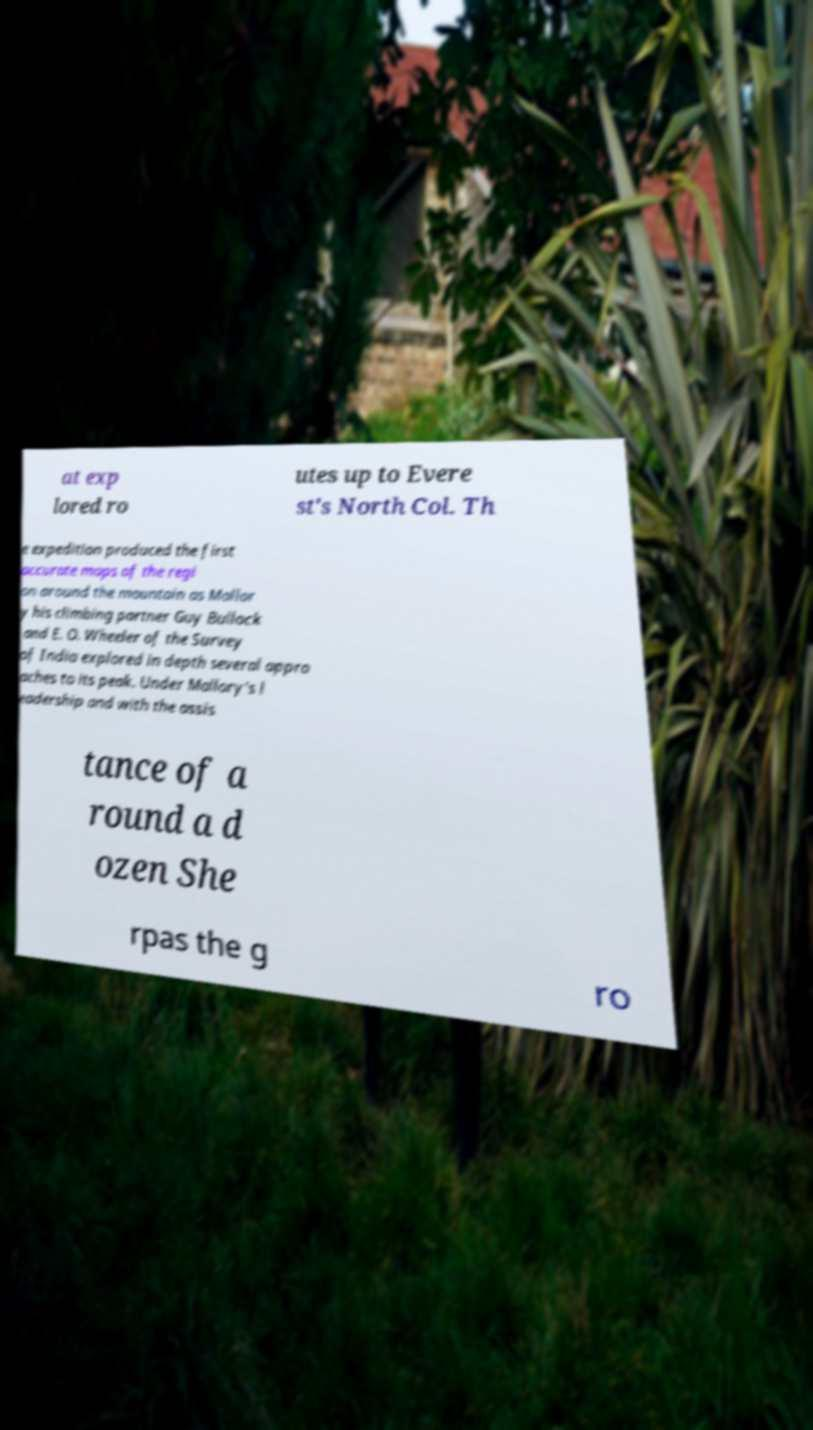Can you read and provide the text displayed in the image?This photo seems to have some interesting text. Can you extract and type it out for me? at exp lored ro utes up to Evere st's North Col. Th e expedition produced the first accurate maps of the regi on around the mountain as Mallor y his climbing partner Guy Bullock and E. O. Wheeler of the Survey of India explored in depth several appro aches to its peak. Under Mallory's l eadership and with the assis tance of a round a d ozen She rpas the g ro 